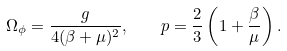<formula> <loc_0><loc_0><loc_500><loc_500>\Omega _ { \phi } = \frac { g } { 4 ( \beta + \mu ) ^ { 2 } } , \quad p = \frac { 2 } { 3 } \left ( 1 + \frac { \beta } { \mu } \right ) .</formula> 